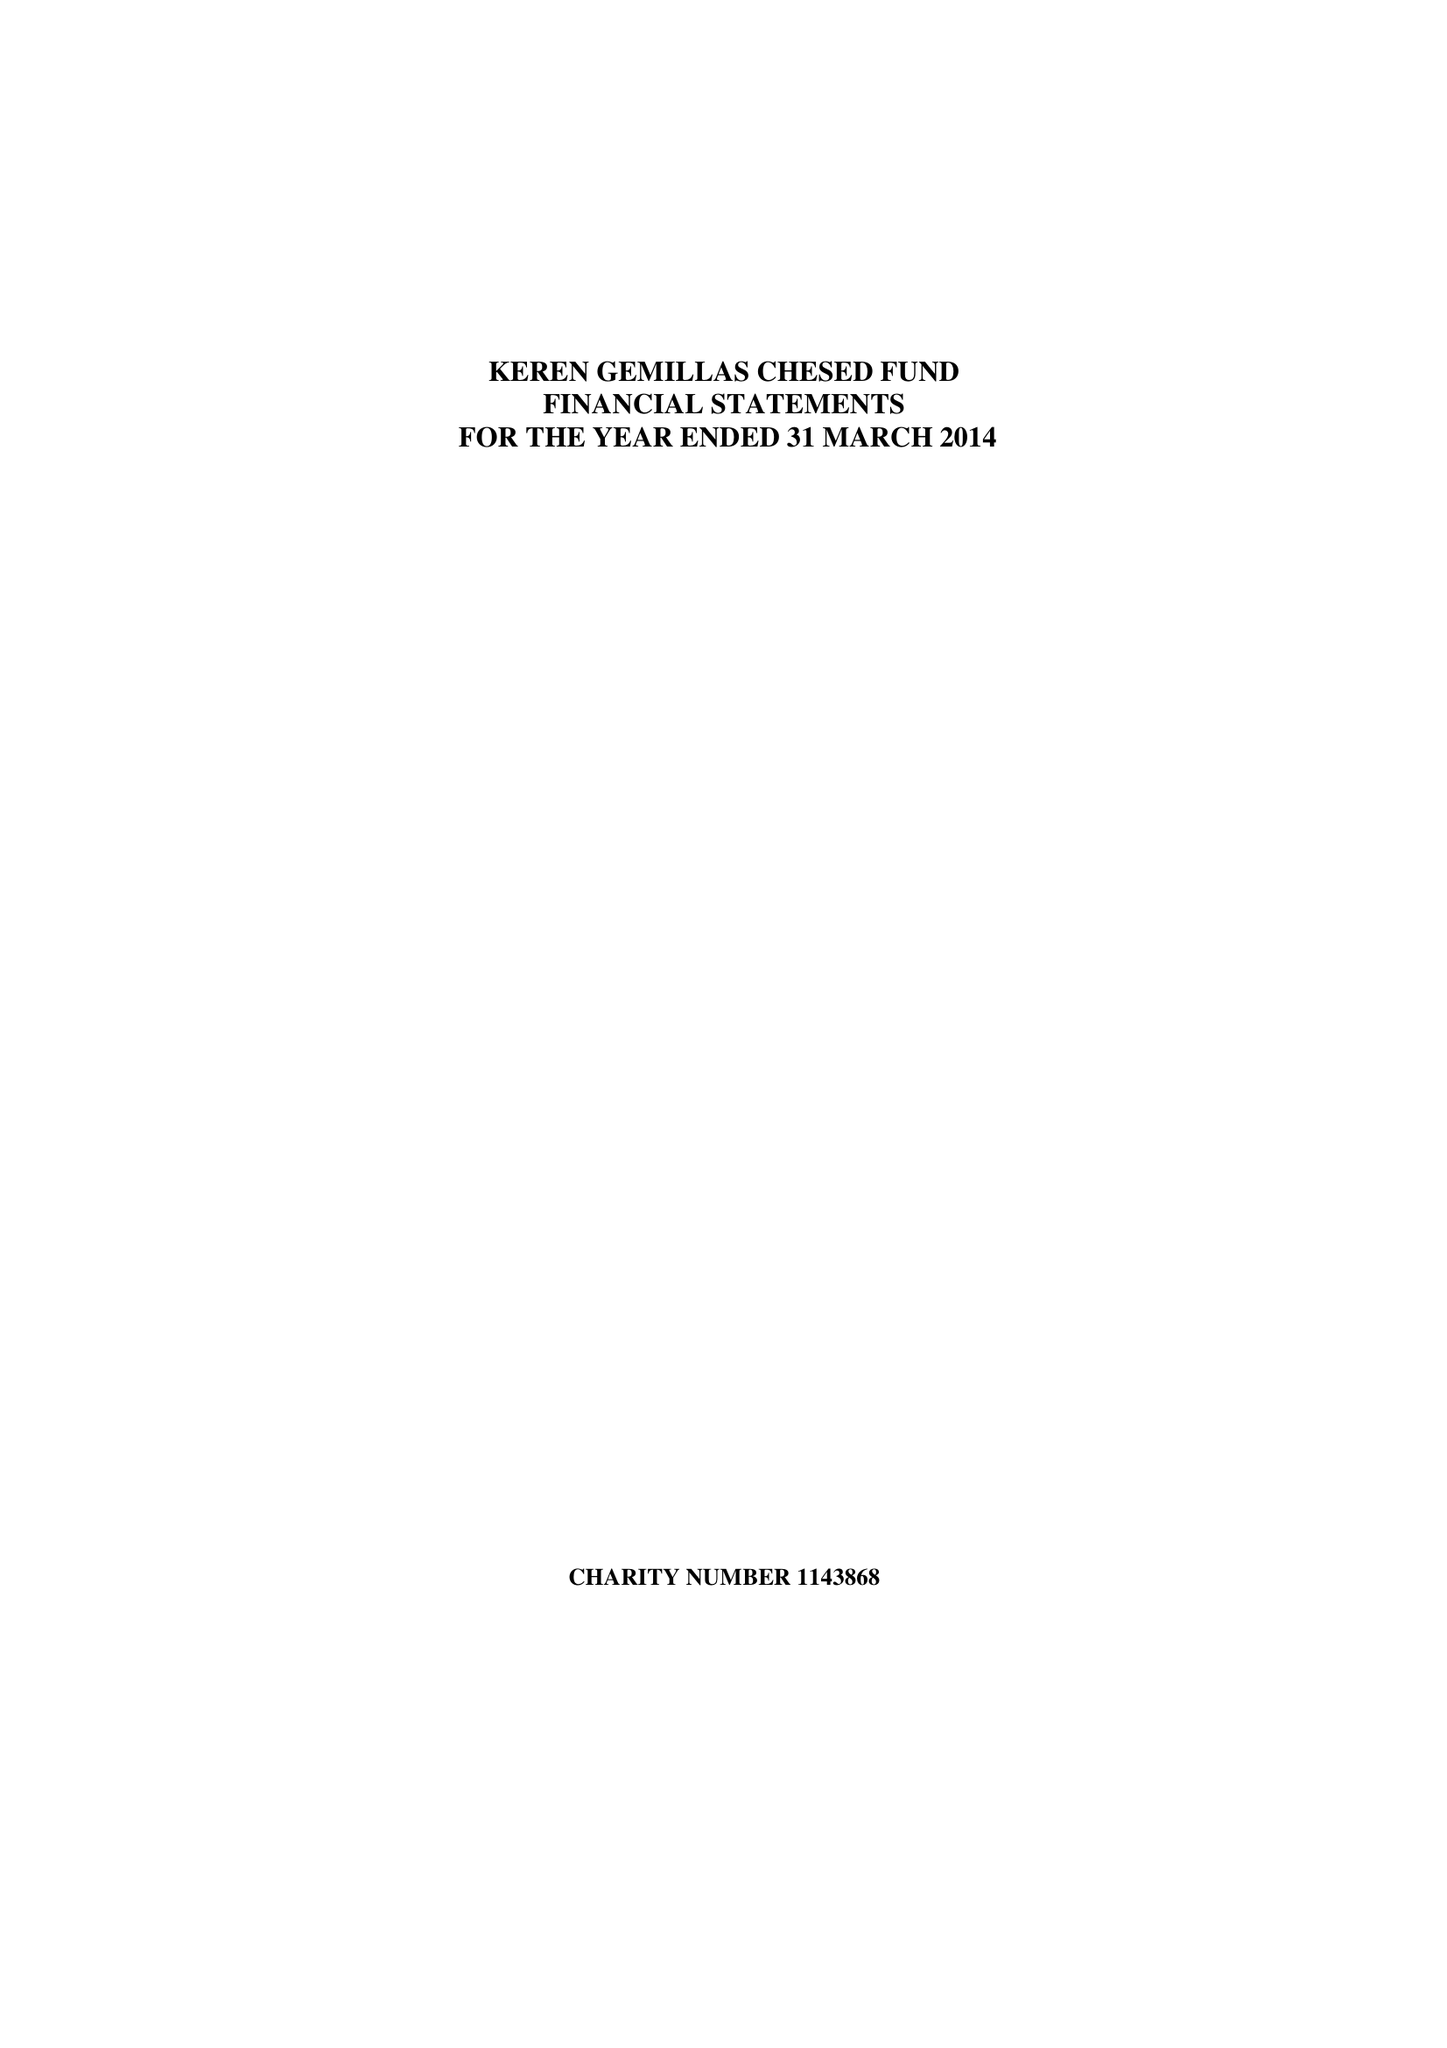What is the value for the address__postcode?
Answer the question using a single word or phrase. M7 4HQ 